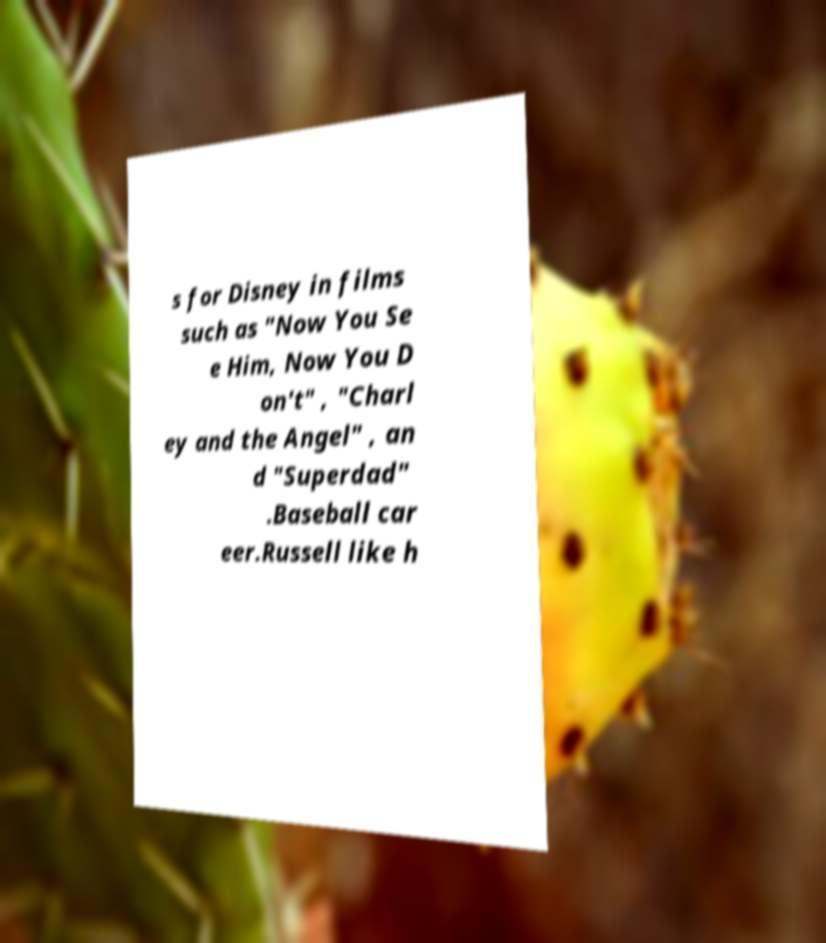What messages or text are displayed in this image? I need them in a readable, typed format. s for Disney in films such as "Now You Se e Him, Now You D on't" , "Charl ey and the Angel" , an d "Superdad" .Baseball car eer.Russell like h 